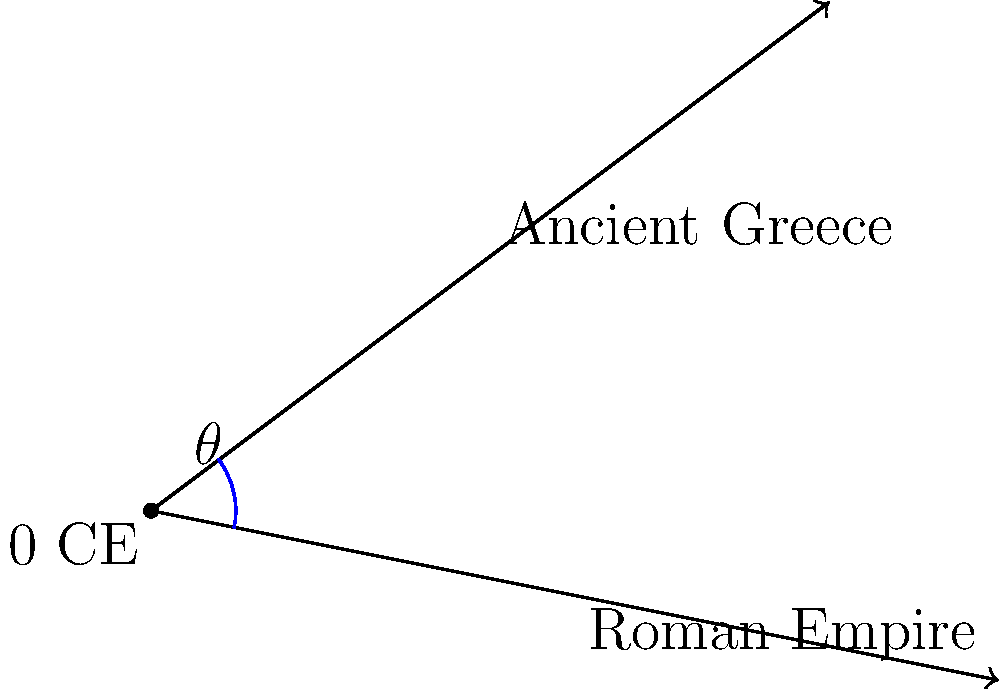In this historical timeline representation, two intersecting lines depict the duration of Ancient Greece and the Roman Empire. If we consider the point of intersection as 0 CE (Common Era), calculate the angle $\theta$ between these two historical periods. Round your answer to the nearest degree. To find the angle between the two historical timelines, we can use the arctangent function and vector coordinates. Let's approach this step-by-step:

1) The Ancient Greece vector is represented by point A(4,3).
2) The Roman Empire vector is represented by point B(5,-1).

3) Calculate the angle for Ancient Greece:
   $\theta_1 = \arctan(\frac{3}{4})$

4) Calculate the angle for Roman Empire:
   $\theta_2 = \arctan(\frac{-1}{5})$

5) The angle between the vectors is the absolute difference:
   $\theta = |\theta_1 - \theta_2|$

6) Using the atan2 function for more precise calculation:
   $\theta = |\arctan2(3,4) - \arctan2(-1,5)|$

7) Convert to degrees:
   $\theta = |\arctan2(3,4) - \arctan2(-1,5)| \cdot \frac{180}{\pi}$

8) Calculate:
   $\theta \approx 36.87°$

9) Rounding to the nearest degree:
   $\theta \approx 37°$
Answer: 37° 